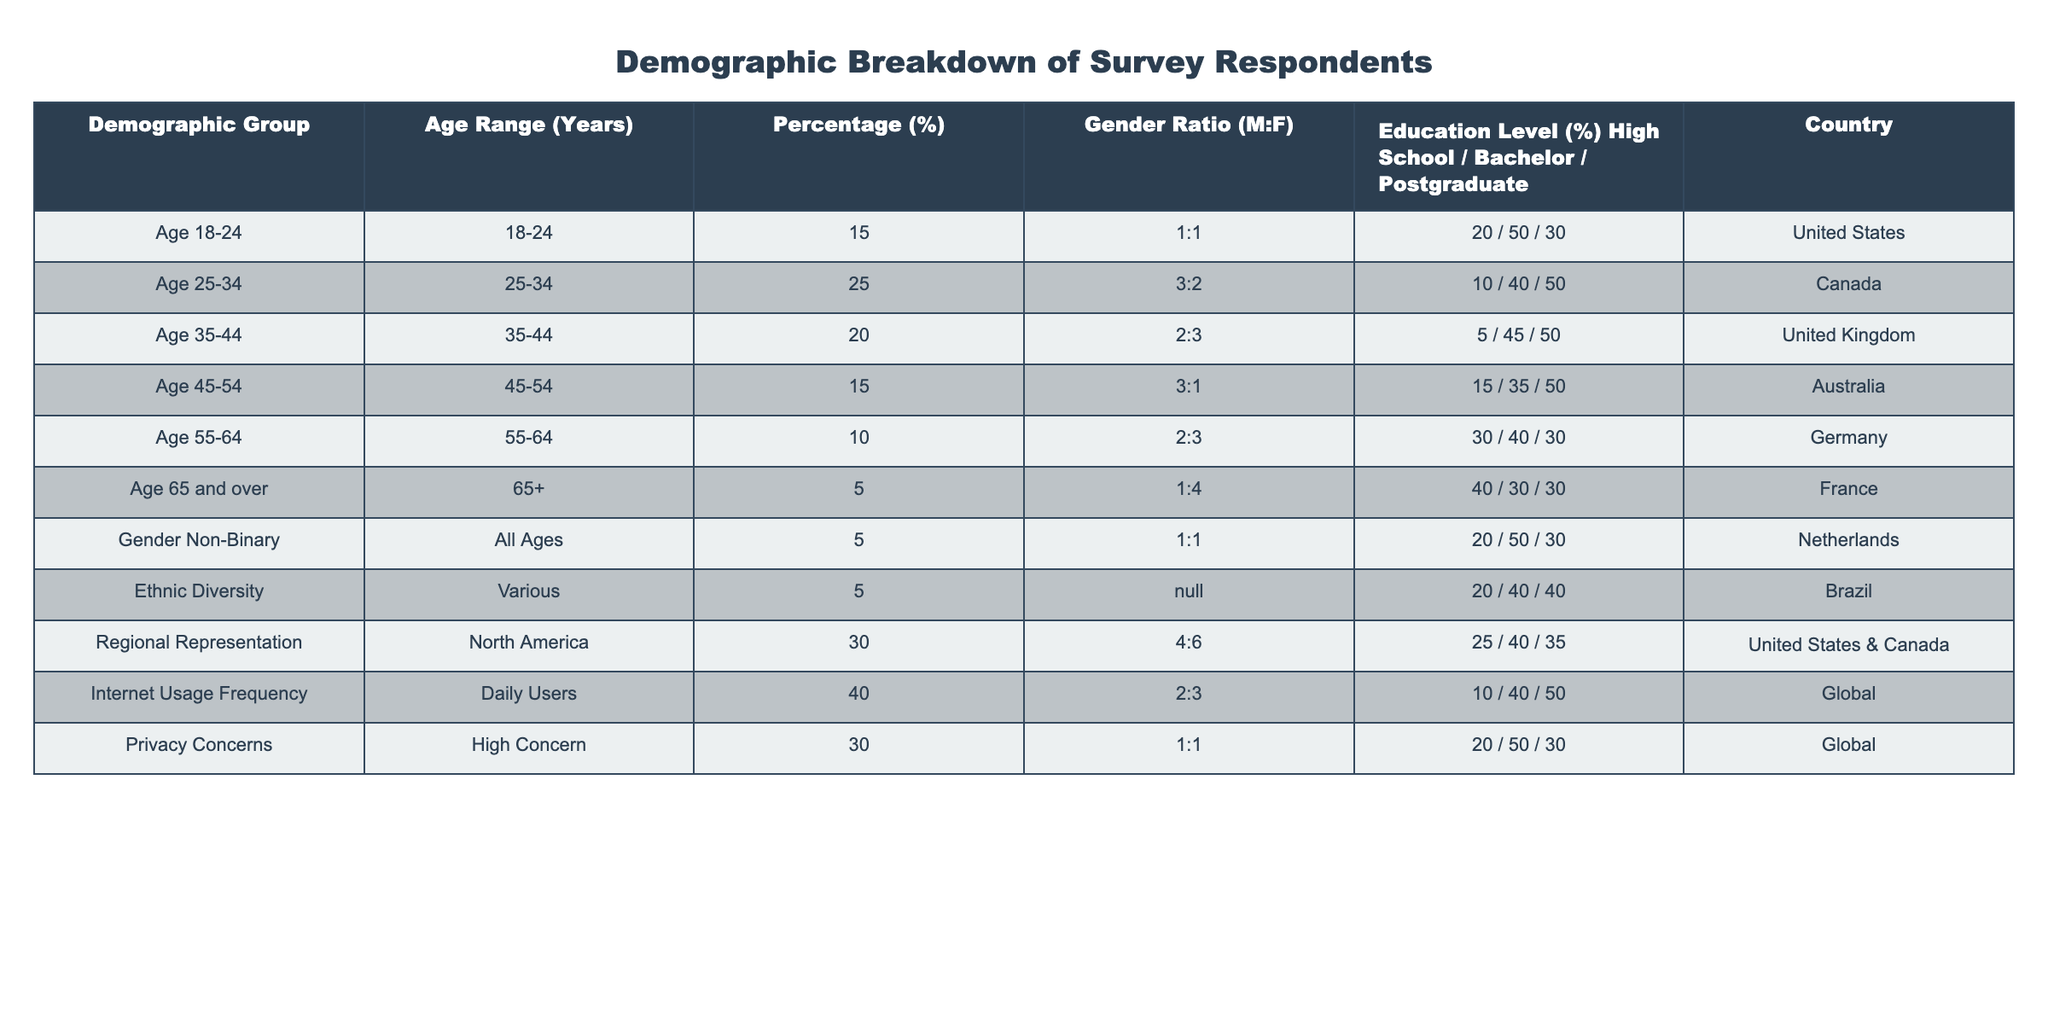What is the percentage of respondents aged 25-34? From the table, we look for the row corresponding to the age group "25-34". The "Percentage (%)" column shows that it is 25%.
Answer: 25% Which demographic group has the highest percentage representation in the survey? By examining the "Percentage (%)" column for each demographic group, we find that "Internet Usage Frequency" has the highest percentage at 40%.
Answer: 40% What is the gender ratio for respondents aged 45-54? The "Gender Ratio (M:F)" for the age group "45-54" is listed as "3:1".
Answer: 3:1 How many demographic groups have a high school education percentage greater than 20%? We check the "Education Level (%) High School" across each demographic group and find that "Age 55-64", "Age 45-54", and "Regional Representation" have high school education percentages greater than 20%. This amounts to three groups.
Answer: 3 Is there any demographic group with zero representation in the 65 and over age range? By examining the table, the "Age 65 and over" group shows a representation of 5%. Therefore, there are no groups with zero representation in this range.
Answer: No What is the average percentage of respondents across all age groups? We gather the percentages of all the age groups (15, 25, 20, 15, 10, 5) and calculate the average: (15 + 25 + 20 + 15 + 10 + 5) / 6 = 15.
Answer: 15 Does the privacy concern demographic group have an equal number of male and female respondents? Looking at the "Gender Ratio (M:F)" column for "Privacy Concerns", it indicates a ratio of 1:1, which means there are equal numbers of male and female respondents.
Answer: Yes Which country has the highest representation from respondents aged 18-24? From the table, the "Age 18-24" group is specifically listed under the "Country" column as "United States", indicating it has the highest representation in this demographic.
Answer: United States What proportion of respondents come from North America? The "Regional Representation" indicates 30% of respondents are from North America, as highlighted in the "Percentage (%)" column for that demographic group.
Answer: 30% Compare the percentage of daily internet users to those with high privacy concerns. Is it higher? Looking at their percentages, "Daily Users" is at 40% and "High Concern" is at 30%. Since 40% > 30%, daily internet users have a higher percentage.
Answer: Yes Which age range has the lowest percentage of respondents? The table shows that the "Age 65 and over" demographic group has the lowest percentage of respondents at 5%.
Answer: 5% 